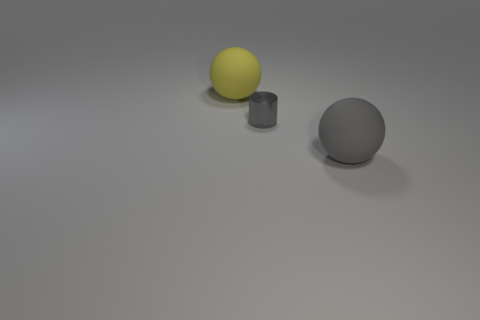Add 2 rubber spheres. How many objects exist? 5 Subtract all cylinders. How many objects are left? 2 Subtract 0 yellow cylinders. How many objects are left? 3 Subtract all big gray things. Subtract all big yellow matte spheres. How many objects are left? 1 Add 2 big gray matte spheres. How many big gray matte spheres are left? 3 Add 2 small cylinders. How many small cylinders exist? 3 